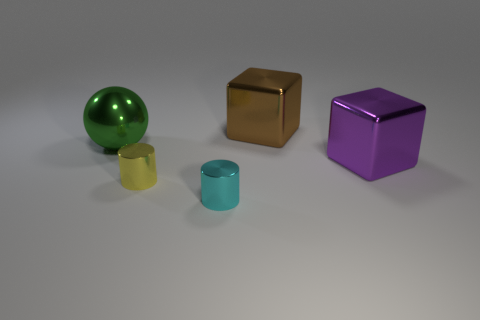Add 2 small yellow metal cubes. How many objects exist? 7 Add 2 cyan objects. How many cyan objects exist? 3 Subtract all cyan cylinders. How many cylinders are left? 1 Subtract 0 purple spheres. How many objects are left? 5 Subtract all cylinders. How many objects are left? 3 Subtract 2 blocks. How many blocks are left? 0 Subtract all blue cubes. Subtract all blue spheres. How many cubes are left? 2 Subtract all blue spheres. How many red blocks are left? 0 Subtract all small things. Subtract all spheres. How many objects are left? 2 Add 1 brown objects. How many brown objects are left? 2 